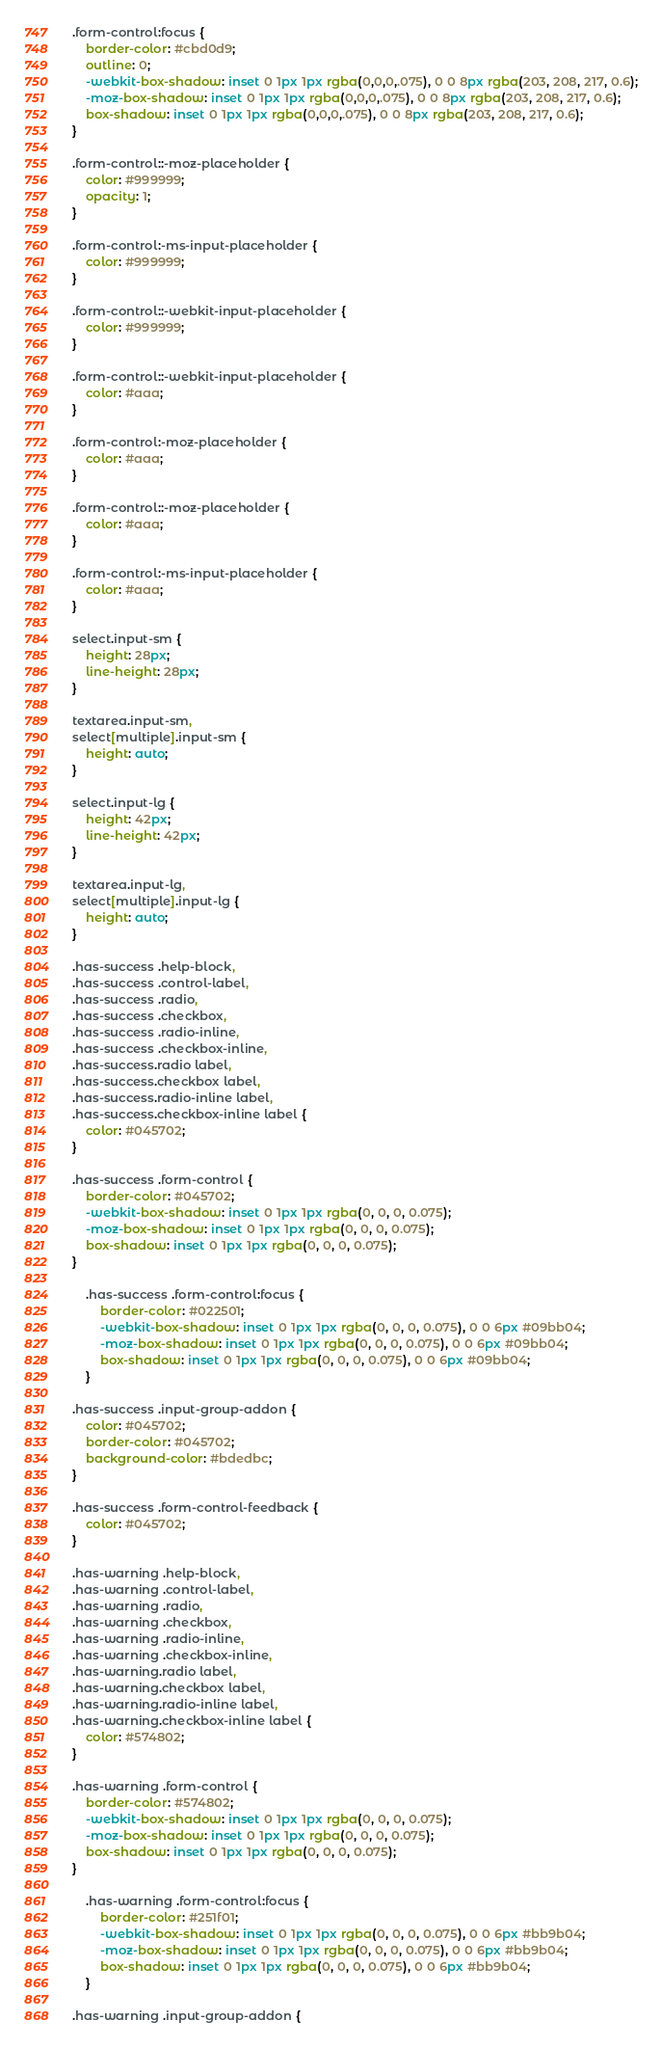Convert code to text. <code><loc_0><loc_0><loc_500><loc_500><_CSS_>.form-control:focus {
    border-color: #cbd0d9;
    outline: 0;
    -webkit-box-shadow: inset 0 1px 1px rgba(0,0,0,.075), 0 0 8px rgba(203, 208, 217, 0.6);
    -moz-box-shadow: inset 0 1px 1px rgba(0,0,0,.075), 0 0 8px rgba(203, 208, 217, 0.6);
    box-shadow: inset 0 1px 1px rgba(0,0,0,.075), 0 0 8px rgba(203, 208, 217, 0.6);
}

.form-control::-moz-placeholder {
    color: #999999;
    opacity: 1;
}

.form-control:-ms-input-placeholder {
    color: #999999;
}

.form-control::-webkit-input-placeholder {
    color: #999999;
}

.form-control::-webkit-input-placeholder {
    color: #aaa;
}

.form-control:-moz-placeholder {
    color: #aaa;
}

.form-control::-moz-placeholder {
    color: #aaa;
}

.form-control:-ms-input-placeholder {
    color: #aaa;
}

select.input-sm {
    height: 28px;
    line-height: 28px;
}

textarea.input-sm,
select[multiple].input-sm {
    height: auto;
}

select.input-lg {
    height: 42px;
    line-height: 42px;
}

textarea.input-lg,
select[multiple].input-lg {
    height: auto;
}

.has-success .help-block,
.has-success .control-label,
.has-success .radio,
.has-success .checkbox,
.has-success .radio-inline,
.has-success .checkbox-inline,
.has-success.radio label,
.has-success.checkbox label,
.has-success.radio-inline label,
.has-success.checkbox-inline label {
    color: #045702;
}

.has-success .form-control {
    border-color: #045702;
    -webkit-box-shadow: inset 0 1px 1px rgba(0, 0, 0, 0.075);
    -moz-box-shadow: inset 0 1px 1px rgba(0, 0, 0, 0.075);
    box-shadow: inset 0 1px 1px rgba(0, 0, 0, 0.075);
}

    .has-success .form-control:focus {
        border-color: #022501;
        -webkit-box-shadow: inset 0 1px 1px rgba(0, 0, 0, 0.075), 0 0 6px #09bb04;
        -moz-box-shadow: inset 0 1px 1px rgba(0, 0, 0, 0.075), 0 0 6px #09bb04;
        box-shadow: inset 0 1px 1px rgba(0, 0, 0, 0.075), 0 0 6px #09bb04;
    }

.has-success .input-group-addon {
    color: #045702;
    border-color: #045702;
    background-color: #bdedbc;
}

.has-success .form-control-feedback {
    color: #045702;
}

.has-warning .help-block,
.has-warning .control-label,
.has-warning .radio,
.has-warning .checkbox,
.has-warning .radio-inline,
.has-warning .checkbox-inline,
.has-warning.radio label,
.has-warning.checkbox label,
.has-warning.radio-inline label,
.has-warning.checkbox-inline label {
    color: #574802;
}

.has-warning .form-control {
    border-color: #574802;
    -webkit-box-shadow: inset 0 1px 1px rgba(0, 0, 0, 0.075);
    -moz-box-shadow: inset 0 1px 1px rgba(0, 0, 0, 0.075);
    box-shadow: inset 0 1px 1px rgba(0, 0, 0, 0.075);
}

    .has-warning .form-control:focus {
        border-color: #251f01;
        -webkit-box-shadow: inset 0 1px 1px rgba(0, 0, 0, 0.075), 0 0 6px #bb9b04;
        -moz-box-shadow: inset 0 1px 1px rgba(0, 0, 0, 0.075), 0 0 6px #bb9b04;
        box-shadow: inset 0 1px 1px rgba(0, 0, 0, 0.075), 0 0 6px #bb9b04;
    }

.has-warning .input-group-addon {</code> 